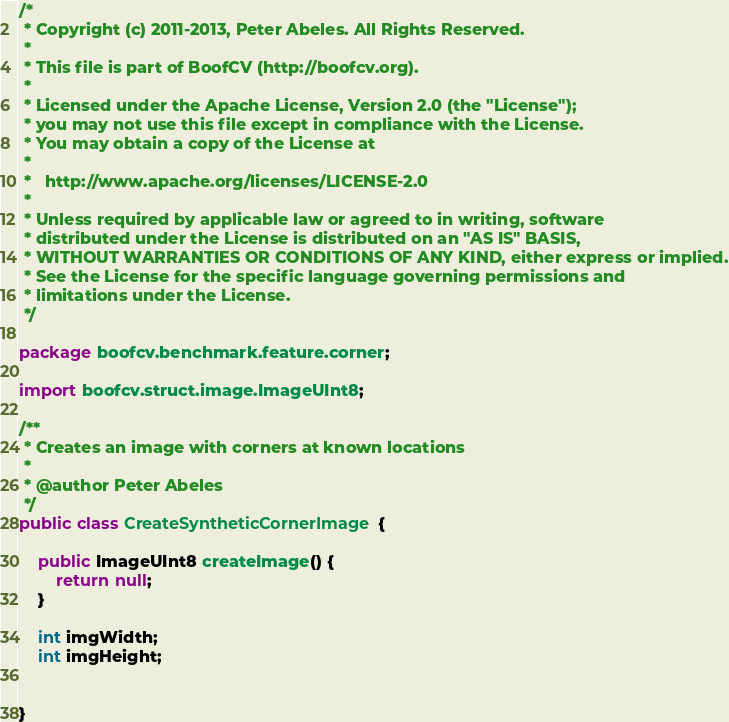<code> <loc_0><loc_0><loc_500><loc_500><_Java_>/*
 * Copyright (c) 2011-2013, Peter Abeles. All Rights Reserved.
 *
 * This file is part of BoofCV (http://boofcv.org).
 *
 * Licensed under the Apache License, Version 2.0 (the "License");
 * you may not use this file except in compliance with the License.
 * You may obtain a copy of the License at
 *
 *   http://www.apache.org/licenses/LICENSE-2.0
 *
 * Unless required by applicable law or agreed to in writing, software
 * distributed under the License is distributed on an "AS IS" BASIS,
 * WITHOUT WARRANTIES OR CONDITIONS OF ANY KIND, either express or implied.
 * See the License for the specific language governing permissions and
 * limitations under the License.
 */

package boofcv.benchmark.feature.corner;

import boofcv.struct.image.ImageUInt8;

/**
 * Creates an image with corners at known locations
 *
 * @author Peter Abeles
 */
public class CreateSyntheticCornerImage {

	public ImageUInt8 createImage() {
		return null;
	}

	int imgWidth;
	int imgHeight;


}
</code> 